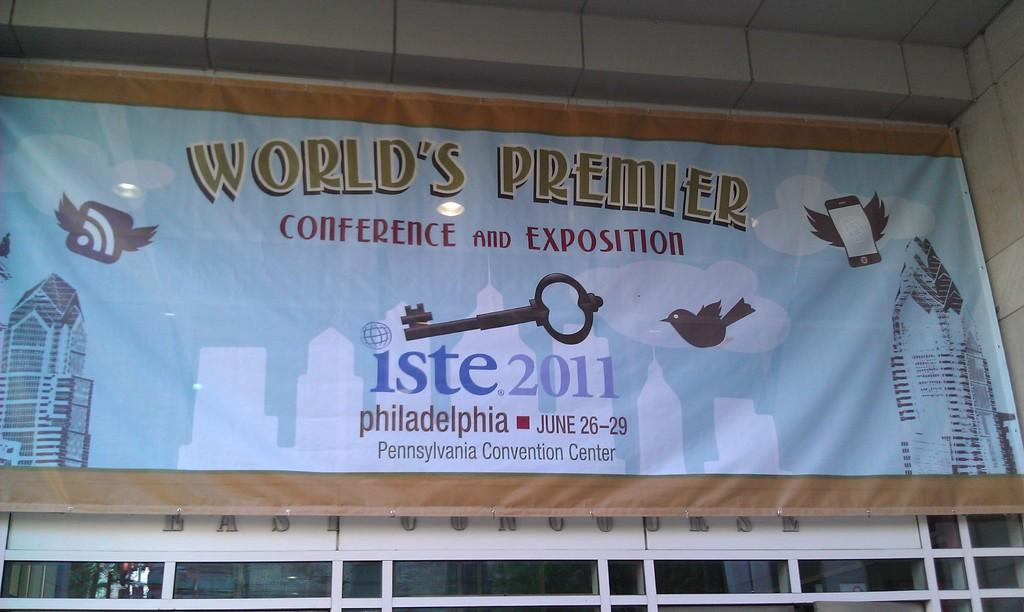<image>
Describe the image concisely. The worlds premier Conference and Exposition in Philadelphia. 